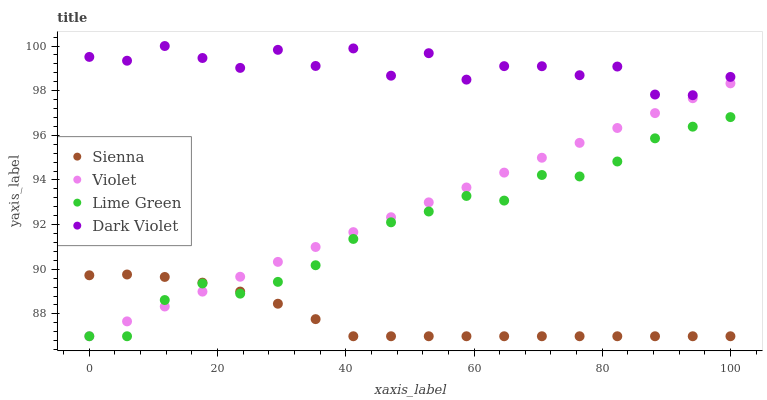Does Sienna have the minimum area under the curve?
Answer yes or no. Yes. Does Dark Violet have the maximum area under the curve?
Answer yes or no. Yes. Does Lime Green have the minimum area under the curve?
Answer yes or no. No. Does Lime Green have the maximum area under the curve?
Answer yes or no. No. Is Violet the smoothest?
Answer yes or no. Yes. Is Dark Violet the roughest?
Answer yes or no. Yes. Is Lime Green the smoothest?
Answer yes or no. No. Is Lime Green the roughest?
Answer yes or no. No. Does Sienna have the lowest value?
Answer yes or no. Yes. Does Dark Violet have the lowest value?
Answer yes or no. No. Does Dark Violet have the highest value?
Answer yes or no. Yes. Does Lime Green have the highest value?
Answer yes or no. No. Is Violet less than Dark Violet?
Answer yes or no. Yes. Is Dark Violet greater than Sienna?
Answer yes or no. Yes. Does Lime Green intersect Sienna?
Answer yes or no. Yes. Is Lime Green less than Sienna?
Answer yes or no. No. Is Lime Green greater than Sienna?
Answer yes or no. No. Does Violet intersect Dark Violet?
Answer yes or no. No. 